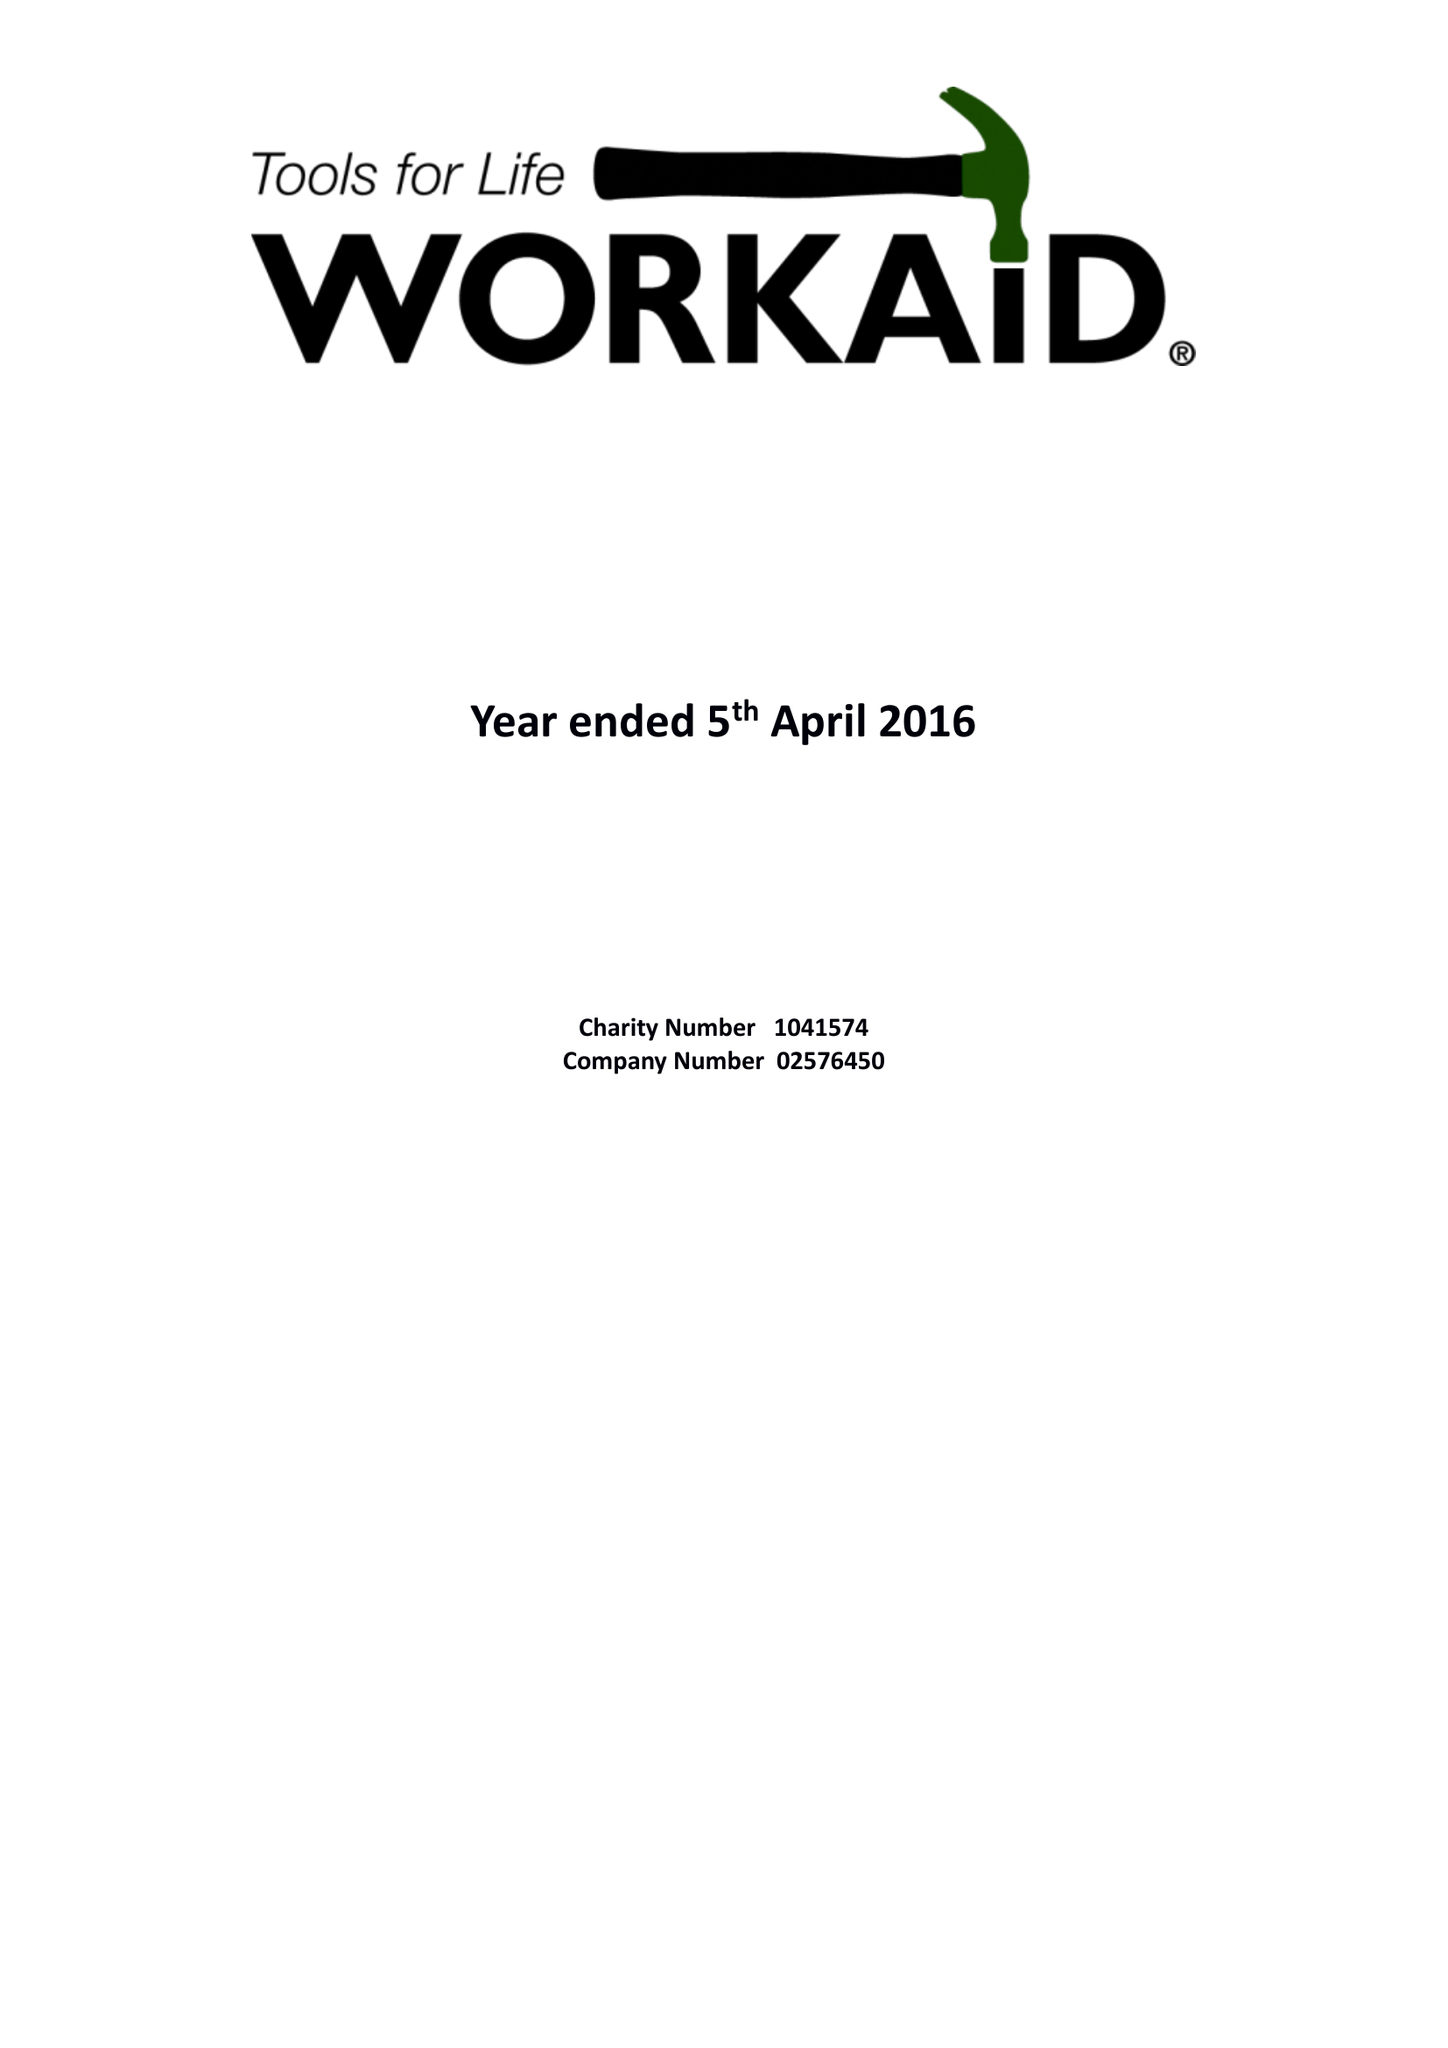What is the value for the charity_number?
Answer the question using a single word or phrase. 1041574 